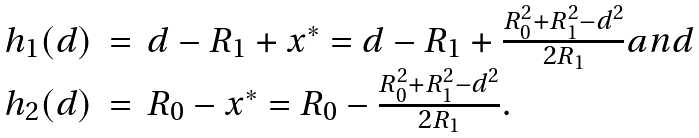Convert formula to latex. <formula><loc_0><loc_0><loc_500><loc_500>\begin{array} { l l l } h _ { 1 } ( d ) & = & d - R _ { 1 } + x ^ { * } = d - R _ { 1 } + \frac { R _ { 0 } ^ { 2 } + R _ { 1 } ^ { 2 } - d ^ { 2 } } { 2 R _ { 1 } } a n d \\ h _ { 2 } ( d ) & = & R _ { 0 } - x ^ { * } = R _ { 0 } - \frac { R _ { 0 } ^ { 2 } + R _ { 1 } ^ { 2 } - d ^ { 2 } } { 2 R _ { 1 } } . \end{array}</formula> 